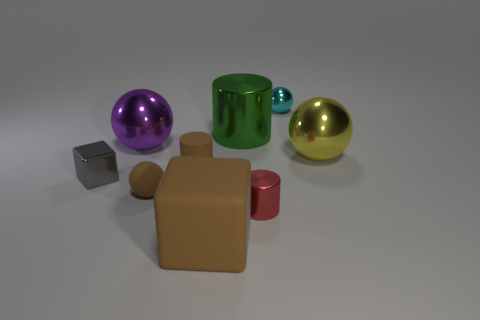Add 1 yellow balls. How many objects exist? 10 Subtract all shiny balls. How many balls are left? 1 Subtract all green cylinders. How many cylinders are left? 2 Subtract all cylinders. How many objects are left? 6 Subtract all cyan spheres. Subtract all large purple metallic balls. How many objects are left? 7 Add 5 purple things. How many purple things are left? 6 Add 3 small cyan objects. How many small cyan objects exist? 4 Subtract 0 gray spheres. How many objects are left? 9 Subtract 2 cylinders. How many cylinders are left? 1 Subtract all cyan cubes. Subtract all green spheres. How many cubes are left? 2 